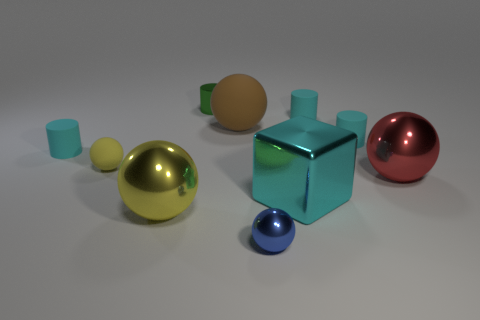What is the shape of the big metal thing that is the same color as the tiny matte sphere?
Your response must be concise. Sphere. How many balls are both left of the cube and in front of the tiny yellow rubber sphere?
Keep it short and to the point. 2. How many other things are the same material as the cyan block?
Your answer should be compact. 4. Are the tiny cyan cylinder that is left of the small blue metal object and the blue ball made of the same material?
Offer a terse response. No. What is the size of the cyan matte thing on the left side of the small ball behind the metal sphere that is behind the large yellow metallic object?
Ensure brevity in your answer.  Small. How many other things are there of the same color as the small matte sphere?
Offer a very short reply. 1. There is a red shiny object that is the same size as the brown thing; what is its shape?
Your answer should be very brief. Sphere. What is the size of the cyan cylinder on the left side of the brown rubber sphere?
Provide a succinct answer. Small. Does the small rubber cylinder that is behind the brown matte sphere have the same color as the metal sphere that is right of the small blue ball?
Keep it short and to the point. No. There is a cyan object that is in front of the cyan rubber cylinder on the left side of the big metal ball left of the small metal ball; what is it made of?
Your response must be concise. Metal. 